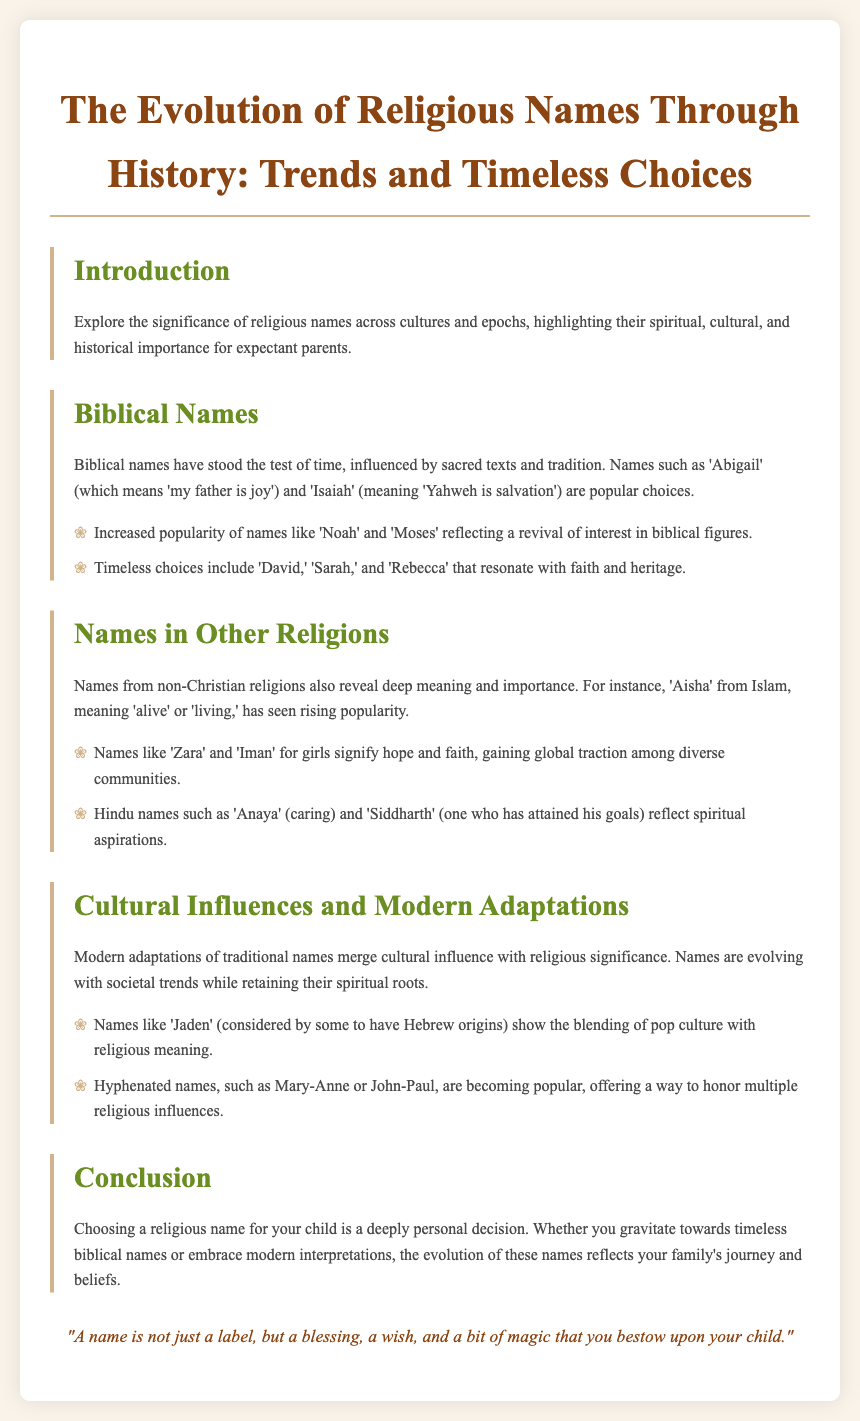What are two popular biblical names mentioned? The document lists 'Abigail' and 'Isaiah' as popular biblical names influenced by sacred texts.
Answer: Abigail, Isaiah Which name means 'alive' or 'living'? The name 'Aisha' from Islam means 'alive' or 'living' as mentioned in the section about names in other religions.
Answer: Aisha What is a modern adaptation of a name discussed? The name 'Jaden' is mentioned as a modern adaptation that is considered to have Hebrew origins.
Answer: Jaden What does 'Siddharth' mean? 'Siddharth' is defined in the document as meaning 'one who has attained his goals' from Hindu names.
Answer: One who has attained his goals Which hyphenated names are becoming popular? The document states that names like 'Mary-Anne' and 'John-Paul' are becoming popular as hyphenated names.
Answer: Mary-Anne, John-Paul What is the main focus of the document? The main focus of the document is the evolution of religious names through history and their significance for expectant parents.
Answer: Evolution of religious names Which biblical figure names have increased in popularity? The document refers to names like 'Noah' and 'Moses' reflecting a revival of interest among biblical figures.
Answer: Noah, Moses What cultural influences affect modern names? The document mentions that modern names are evolving with societal trends while retaining their spiritual roots.
Answer: Societal trends 